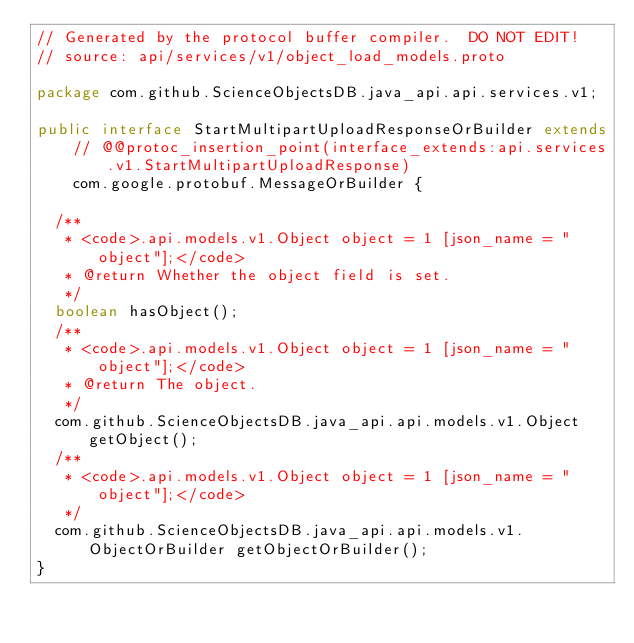Convert code to text. <code><loc_0><loc_0><loc_500><loc_500><_Java_>// Generated by the protocol buffer compiler.  DO NOT EDIT!
// source: api/services/v1/object_load_models.proto

package com.github.ScienceObjectsDB.java_api.api.services.v1;

public interface StartMultipartUploadResponseOrBuilder extends
    // @@protoc_insertion_point(interface_extends:api.services.v1.StartMultipartUploadResponse)
    com.google.protobuf.MessageOrBuilder {

  /**
   * <code>.api.models.v1.Object object = 1 [json_name = "object"];</code>
   * @return Whether the object field is set.
   */
  boolean hasObject();
  /**
   * <code>.api.models.v1.Object object = 1 [json_name = "object"];</code>
   * @return The object.
   */
  com.github.ScienceObjectsDB.java_api.api.models.v1.Object getObject();
  /**
   * <code>.api.models.v1.Object object = 1 [json_name = "object"];</code>
   */
  com.github.ScienceObjectsDB.java_api.api.models.v1.ObjectOrBuilder getObjectOrBuilder();
}
</code> 